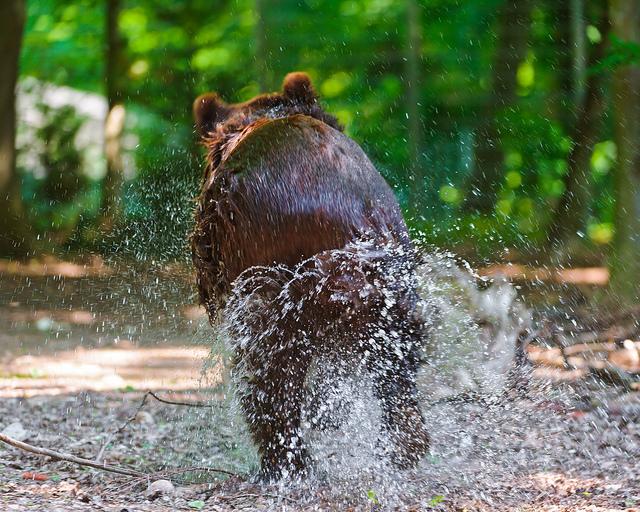Is the bear swimming?
Answer briefly. No. What animal is running through the water?
Write a very short answer. Bear. What is this animal?
Be succinct. Bear. 